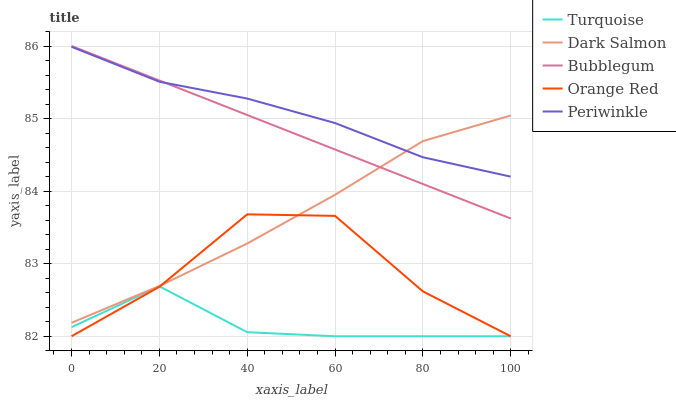Does Turquoise have the minimum area under the curve?
Answer yes or no. Yes. Does Periwinkle have the maximum area under the curve?
Answer yes or no. Yes. Does Dark Salmon have the minimum area under the curve?
Answer yes or no. No. Does Dark Salmon have the maximum area under the curve?
Answer yes or no. No. Is Bubblegum the smoothest?
Answer yes or no. Yes. Is Orange Red the roughest?
Answer yes or no. Yes. Is Periwinkle the smoothest?
Answer yes or no. No. Is Periwinkle the roughest?
Answer yes or no. No. Does Turquoise have the lowest value?
Answer yes or no. Yes. Does Dark Salmon have the lowest value?
Answer yes or no. No. Does Bubblegum have the highest value?
Answer yes or no. Yes. Does Periwinkle have the highest value?
Answer yes or no. No. Is Orange Red less than Periwinkle?
Answer yes or no. Yes. Is Bubblegum greater than Orange Red?
Answer yes or no. Yes. Does Periwinkle intersect Bubblegum?
Answer yes or no. Yes. Is Periwinkle less than Bubblegum?
Answer yes or no. No. Is Periwinkle greater than Bubblegum?
Answer yes or no. No. Does Orange Red intersect Periwinkle?
Answer yes or no. No. 